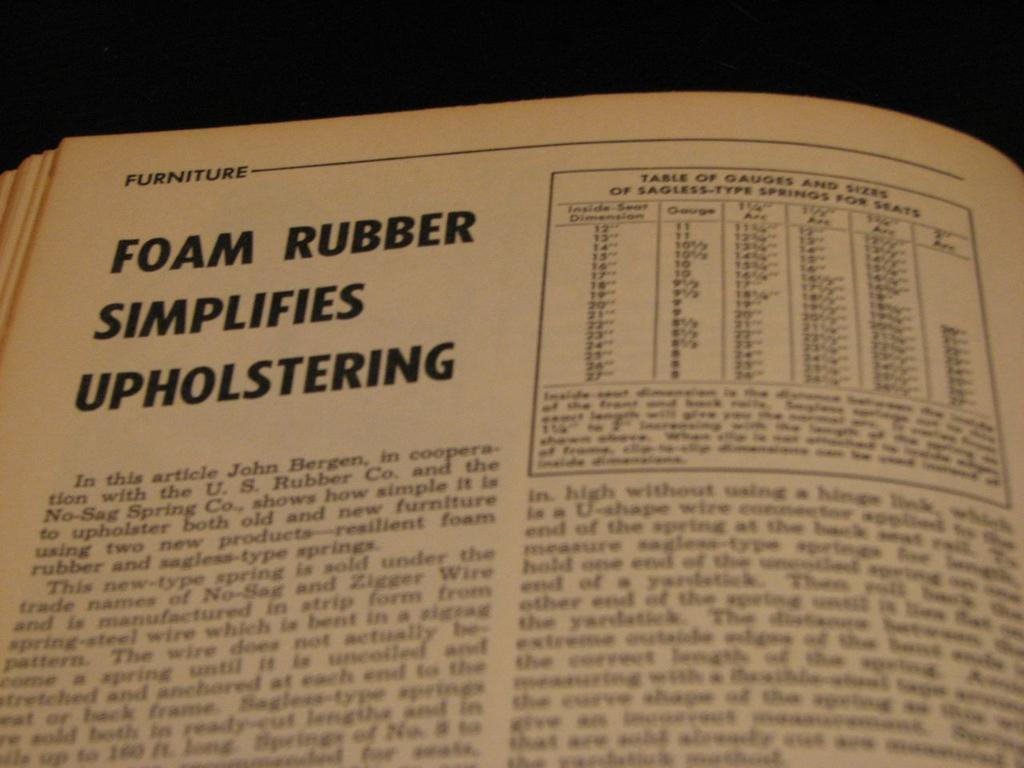Provide a one-sentence caption for the provided image. open book on the page of foam rubber simplifies. 